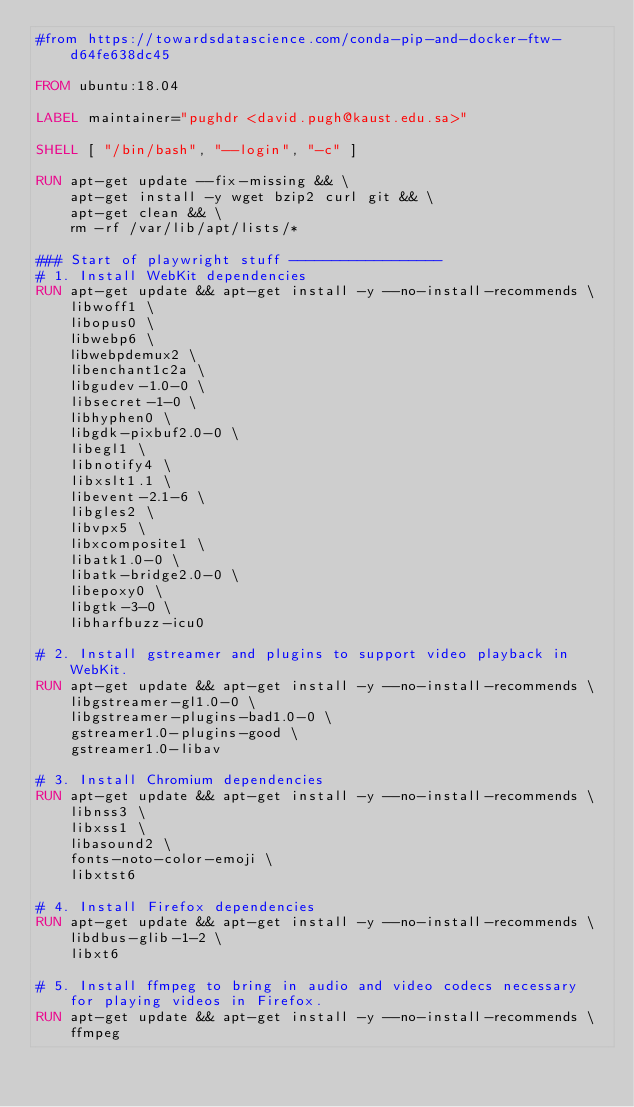<code> <loc_0><loc_0><loc_500><loc_500><_Dockerfile_>#from https://towardsdatascience.com/conda-pip-and-docker-ftw-d64fe638dc45

FROM ubuntu:18.04

LABEL maintainer="pughdr <david.pugh@kaust.edu.sa>"

SHELL [ "/bin/bash", "--login", "-c" ]

RUN apt-get update --fix-missing && \
    apt-get install -y wget bzip2 curl git && \
    apt-get clean && \
    rm -rf /var/lib/apt/lists/*

### Start of playwright stuff ------------------
# 1. Install WebKit dependencies
RUN apt-get update && apt-get install -y --no-install-recommends \
    libwoff1 \
    libopus0 \
    libwebp6 \
    libwebpdemux2 \
    libenchant1c2a \
    libgudev-1.0-0 \
    libsecret-1-0 \
    libhyphen0 \
    libgdk-pixbuf2.0-0 \
    libegl1 \
    libnotify4 \
    libxslt1.1 \
    libevent-2.1-6 \
    libgles2 \
    libvpx5 \
    libxcomposite1 \
    libatk1.0-0 \
    libatk-bridge2.0-0 \
    libepoxy0 \
    libgtk-3-0 \
    libharfbuzz-icu0

# 2. Install gstreamer and plugins to support video playback in WebKit.
RUN apt-get update && apt-get install -y --no-install-recommends \
    libgstreamer-gl1.0-0 \
    libgstreamer-plugins-bad1.0-0 \
    gstreamer1.0-plugins-good \
    gstreamer1.0-libav

# 3. Install Chromium dependencies
RUN apt-get update && apt-get install -y --no-install-recommends \
    libnss3 \
    libxss1 \
    libasound2 \
    fonts-noto-color-emoji \
    libxtst6

# 4. Install Firefox dependencies
RUN apt-get update && apt-get install -y --no-install-recommends \
    libdbus-glib-1-2 \
    libxt6

# 5. Install ffmpeg to bring in audio and video codecs necessary for playing videos in Firefox.
RUN apt-get update && apt-get install -y --no-install-recommends \
    ffmpeg
</code> 